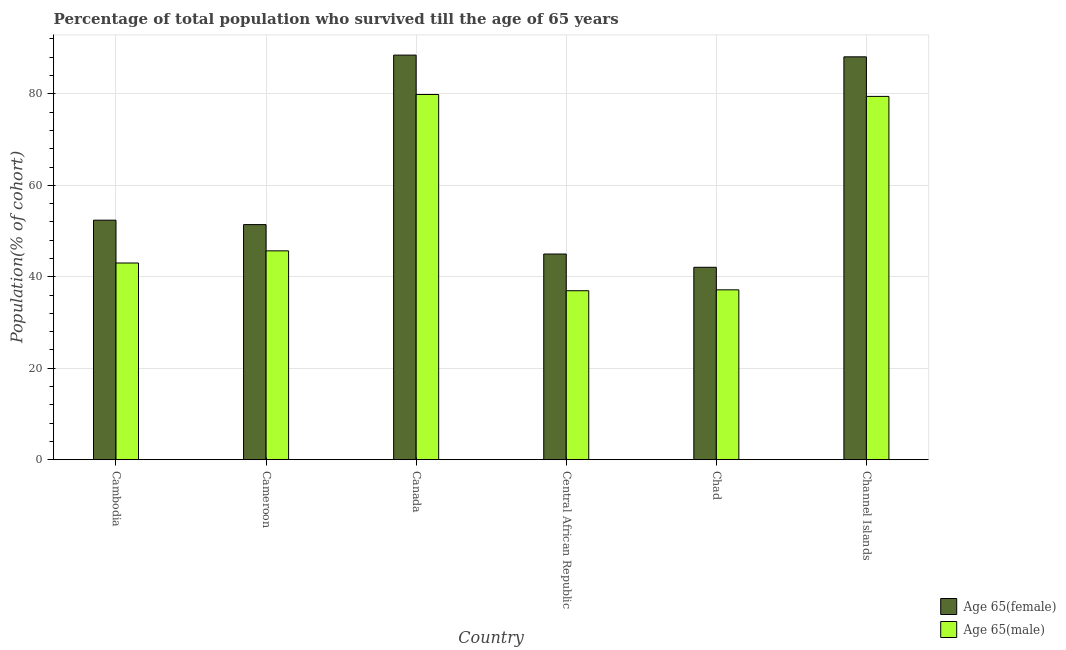Are the number of bars on each tick of the X-axis equal?
Offer a terse response. Yes. How many bars are there on the 4th tick from the left?
Provide a succinct answer. 2. How many bars are there on the 5th tick from the right?
Provide a succinct answer. 2. What is the label of the 6th group of bars from the left?
Keep it short and to the point. Channel Islands. In how many cases, is the number of bars for a given country not equal to the number of legend labels?
Your response must be concise. 0. What is the percentage of male population who survived till age of 65 in Canada?
Ensure brevity in your answer.  79.86. Across all countries, what is the maximum percentage of female population who survived till age of 65?
Provide a succinct answer. 88.47. Across all countries, what is the minimum percentage of female population who survived till age of 65?
Keep it short and to the point. 42.07. In which country was the percentage of male population who survived till age of 65 maximum?
Provide a short and direct response. Canada. In which country was the percentage of female population who survived till age of 65 minimum?
Offer a terse response. Chad. What is the total percentage of male population who survived till age of 65 in the graph?
Your answer should be compact. 322.07. What is the difference between the percentage of male population who survived till age of 65 in Chad and that in Channel Islands?
Give a very brief answer. -42.3. What is the difference between the percentage of female population who survived till age of 65 in Channel Islands and the percentage of male population who survived till age of 65 in Cameroon?
Keep it short and to the point. 42.42. What is the average percentage of male population who survived till age of 65 per country?
Give a very brief answer. 53.68. What is the difference between the percentage of male population who survived till age of 65 and percentage of female population who survived till age of 65 in Canada?
Ensure brevity in your answer.  -8.61. What is the ratio of the percentage of male population who survived till age of 65 in Cameroon to that in Channel Islands?
Offer a terse response. 0.57. Is the percentage of female population who survived till age of 65 in Cameroon less than that in Channel Islands?
Your answer should be compact. Yes. What is the difference between the highest and the second highest percentage of female population who survived till age of 65?
Give a very brief answer. 0.38. What is the difference between the highest and the lowest percentage of male population who survived till age of 65?
Your response must be concise. 42.91. In how many countries, is the percentage of male population who survived till age of 65 greater than the average percentage of male population who survived till age of 65 taken over all countries?
Your answer should be compact. 2. Is the sum of the percentage of male population who survived till age of 65 in Canada and Channel Islands greater than the maximum percentage of female population who survived till age of 65 across all countries?
Keep it short and to the point. Yes. What does the 1st bar from the left in Cameroon represents?
Offer a terse response. Age 65(female). What does the 1st bar from the right in Canada represents?
Keep it short and to the point. Age 65(male). How many countries are there in the graph?
Give a very brief answer. 6. What is the difference between two consecutive major ticks on the Y-axis?
Give a very brief answer. 20. Does the graph contain any zero values?
Your answer should be compact. No. Does the graph contain grids?
Your answer should be compact. Yes. How many legend labels are there?
Provide a succinct answer. 2. What is the title of the graph?
Offer a terse response. Percentage of total population who survived till the age of 65 years. What is the label or title of the X-axis?
Ensure brevity in your answer.  Country. What is the label or title of the Y-axis?
Provide a succinct answer. Population(% of cohort). What is the Population(% of cohort) of Age 65(female) in Cambodia?
Keep it short and to the point. 52.37. What is the Population(% of cohort) in Age 65(male) in Cambodia?
Offer a terse response. 43.01. What is the Population(% of cohort) of Age 65(female) in Cameroon?
Your answer should be compact. 51.41. What is the Population(% of cohort) in Age 65(male) in Cameroon?
Offer a terse response. 45.67. What is the Population(% of cohort) in Age 65(female) in Canada?
Your answer should be very brief. 88.47. What is the Population(% of cohort) in Age 65(male) in Canada?
Ensure brevity in your answer.  79.86. What is the Population(% of cohort) of Age 65(female) in Central African Republic?
Your answer should be very brief. 44.97. What is the Population(% of cohort) in Age 65(male) in Central African Republic?
Your answer should be compact. 36.95. What is the Population(% of cohort) of Age 65(female) in Chad?
Provide a short and direct response. 42.07. What is the Population(% of cohort) of Age 65(male) in Chad?
Your answer should be compact. 37.14. What is the Population(% of cohort) of Age 65(female) in Channel Islands?
Your answer should be compact. 88.09. What is the Population(% of cohort) of Age 65(male) in Channel Islands?
Keep it short and to the point. 79.44. Across all countries, what is the maximum Population(% of cohort) of Age 65(female)?
Ensure brevity in your answer.  88.47. Across all countries, what is the maximum Population(% of cohort) in Age 65(male)?
Provide a succinct answer. 79.86. Across all countries, what is the minimum Population(% of cohort) of Age 65(female)?
Make the answer very short. 42.07. Across all countries, what is the minimum Population(% of cohort) of Age 65(male)?
Ensure brevity in your answer.  36.95. What is the total Population(% of cohort) of Age 65(female) in the graph?
Provide a succinct answer. 367.39. What is the total Population(% of cohort) of Age 65(male) in the graph?
Offer a very short reply. 322.07. What is the difference between the Population(% of cohort) of Age 65(female) in Cambodia and that in Cameroon?
Offer a very short reply. 0.96. What is the difference between the Population(% of cohort) in Age 65(male) in Cambodia and that in Cameroon?
Your response must be concise. -2.66. What is the difference between the Population(% of cohort) of Age 65(female) in Cambodia and that in Canada?
Your answer should be compact. -36.1. What is the difference between the Population(% of cohort) in Age 65(male) in Cambodia and that in Canada?
Your answer should be very brief. -36.85. What is the difference between the Population(% of cohort) of Age 65(female) in Cambodia and that in Central African Republic?
Offer a very short reply. 7.4. What is the difference between the Population(% of cohort) of Age 65(male) in Cambodia and that in Central African Republic?
Keep it short and to the point. 6.06. What is the difference between the Population(% of cohort) of Age 65(female) in Cambodia and that in Chad?
Give a very brief answer. 10.3. What is the difference between the Population(% of cohort) in Age 65(male) in Cambodia and that in Chad?
Make the answer very short. 5.86. What is the difference between the Population(% of cohort) in Age 65(female) in Cambodia and that in Channel Islands?
Offer a very short reply. -35.72. What is the difference between the Population(% of cohort) of Age 65(male) in Cambodia and that in Channel Islands?
Your response must be concise. -36.43. What is the difference between the Population(% of cohort) in Age 65(female) in Cameroon and that in Canada?
Offer a very short reply. -37.06. What is the difference between the Population(% of cohort) in Age 65(male) in Cameroon and that in Canada?
Give a very brief answer. -34.19. What is the difference between the Population(% of cohort) in Age 65(female) in Cameroon and that in Central African Republic?
Provide a succinct answer. 6.44. What is the difference between the Population(% of cohort) of Age 65(male) in Cameroon and that in Central African Republic?
Your response must be concise. 8.72. What is the difference between the Population(% of cohort) in Age 65(female) in Cameroon and that in Chad?
Your answer should be compact. 9.34. What is the difference between the Population(% of cohort) of Age 65(male) in Cameroon and that in Chad?
Keep it short and to the point. 8.52. What is the difference between the Population(% of cohort) in Age 65(female) in Cameroon and that in Channel Islands?
Offer a terse response. -36.68. What is the difference between the Population(% of cohort) of Age 65(male) in Cameroon and that in Channel Islands?
Give a very brief answer. -33.77. What is the difference between the Population(% of cohort) in Age 65(female) in Canada and that in Central African Republic?
Your response must be concise. 43.5. What is the difference between the Population(% of cohort) in Age 65(male) in Canada and that in Central African Republic?
Provide a succinct answer. 42.91. What is the difference between the Population(% of cohort) of Age 65(female) in Canada and that in Chad?
Make the answer very short. 46.4. What is the difference between the Population(% of cohort) in Age 65(male) in Canada and that in Chad?
Provide a succinct answer. 42.71. What is the difference between the Population(% of cohort) in Age 65(female) in Canada and that in Channel Islands?
Provide a succinct answer. 0.38. What is the difference between the Population(% of cohort) in Age 65(male) in Canada and that in Channel Islands?
Provide a short and direct response. 0.41. What is the difference between the Population(% of cohort) of Age 65(female) in Central African Republic and that in Chad?
Your response must be concise. 2.9. What is the difference between the Population(% of cohort) of Age 65(male) in Central African Republic and that in Chad?
Your answer should be compact. -0.2. What is the difference between the Population(% of cohort) in Age 65(female) in Central African Republic and that in Channel Islands?
Provide a short and direct response. -43.12. What is the difference between the Population(% of cohort) of Age 65(male) in Central African Republic and that in Channel Islands?
Ensure brevity in your answer.  -42.49. What is the difference between the Population(% of cohort) in Age 65(female) in Chad and that in Channel Islands?
Keep it short and to the point. -46.02. What is the difference between the Population(% of cohort) in Age 65(male) in Chad and that in Channel Islands?
Keep it short and to the point. -42.3. What is the difference between the Population(% of cohort) of Age 65(female) in Cambodia and the Population(% of cohort) of Age 65(male) in Cameroon?
Your response must be concise. 6.71. What is the difference between the Population(% of cohort) in Age 65(female) in Cambodia and the Population(% of cohort) in Age 65(male) in Canada?
Provide a short and direct response. -27.48. What is the difference between the Population(% of cohort) in Age 65(female) in Cambodia and the Population(% of cohort) in Age 65(male) in Central African Republic?
Ensure brevity in your answer.  15.42. What is the difference between the Population(% of cohort) in Age 65(female) in Cambodia and the Population(% of cohort) in Age 65(male) in Chad?
Offer a terse response. 15.23. What is the difference between the Population(% of cohort) of Age 65(female) in Cambodia and the Population(% of cohort) of Age 65(male) in Channel Islands?
Keep it short and to the point. -27.07. What is the difference between the Population(% of cohort) in Age 65(female) in Cameroon and the Population(% of cohort) in Age 65(male) in Canada?
Keep it short and to the point. -28.45. What is the difference between the Population(% of cohort) of Age 65(female) in Cameroon and the Population(% of cohort) of Age 65(male) in Central African Republic?
Give a very brief answer. 14.46. What is the difference between the Population(% of cohort) of Age 65(female) in Cameroon and the Population(% of cohort) of Age 65(male) in Chad?
Your answer should be compact. 14.27. What is the difference between the Population(% of cohort) in Age 65(female) in Cameroon and the Population(% of cohort) in Age 65(male) in Channel Islands?
Your answer should be very brief. -28.03. What is the difference between the Population(% of cohort) of Age 65(female) in Canada and the Population(% of cohort) of Age 65(male) in Central African Republic?
Provide a succinct answer. 51.52. What is the difference between the Population(% of cohort) of Age 65(female) in Canada and the Population(% of cohort) of Age 65(male) in Chad?
Your response must be concise. 51.33. What is the difference between the Population(% of cohort) of Age 65(female) in Canada and the Population(% of cohort) of Age 65(male) in Channel Islands?
Keep it short and to the point. 9.03. What is the difference between the Population(% of cohort) of Age 65(female) in Central African Republic and the Population(% of cohort) of Age 65(male) in Chad?
Make the answer very short. 7.83. What is the difference between the Population(% of cohort) of Age 65(female) in Central African Republic and the Population(% of cohort) of Age 65(male) in Channel Islands?
Your answer should be compact. -34.47. What is the difference between the Population(% of cohort) in Age 65(female) in Chad and the Population(% of cohort) in Age 65(male) in Channel Islands?
Your response must be concise. -37.37. What is the average Population(% of cohort) of Age 65(female) per country?
Provide a short and direct response. 61.23. What is the average Population(% of cohort) of Age 65(male) per country?
Your answer should be very brief. 53.68. What is the difference between the Population(% of cohort) of Age 65(female) and Population(% of cohort) of Age 65(male) in Cambodia?
Provide a succinct answer. 9.36. What is the difference between the Population(% of cohort) in Age 65(female) and Population(% of cohort) in Age 65(male) in Cameroon?
Your answer should be compact. 5.74. What is the difference between the Population(% of cohort) of Age 65(female) and Population(% of cohort) of Age 65(male) in Canada?
Your response must be concise. 8.61. What is the difference between the Population(% of cohort) in Age 65(female) and Population(% of cohort) in Age 65(male) in Central African Republic?
Make the answer very short. 8.02. What is the difference between the Population(% of cohort) of Age 65(female) and Population(% of cohort) of Age 65(male) in Chad?
Offer a terse response. 4.93. What is the difference between the Population(% of cohort) of Age 65(female) and Population(% of cohort) of Age 65(male) in Channel Islands?
Keep it short and to the point. 8.65. What is the ratio of the Population(% of cohort) of Age 65(female) in Cambodia to that in Cameroon?
Provide a succinct answer. 1.02. What is the ratio of the Population(% of cohort) in Age 65(male) in Cambodia to that in Cameroon?
Your response must be concise. 0.94. What is the ratio of the Population(% of cohort) in Age 65(female) in Cambodia to that in Canada?
Make the answer very short. 0.59. What is the ratio of the Population(% of cohort) in Age 65(male) in Cambodia to that in Canada?
Ensure brevity in your answer.  0.54. What is the ratio of the Population(% of cohort) of Age 65(female) in Cambodia to that in Central African Republic?
Make the answer very short. 1.16. What is the ratio of the Population(% of cohort) of Age 65(male) in Cambodia to that in Central African Republic?
Give a very brief answer. 1.16. What is the ratio of the Population(% of cohort) of Age 65(female) in Cambodia to that in Chad?
Offer a terse response. 1.24. What is the ratio of the Population(% of cohort) in Age 65(male) in Cambodia to that in Chad?
Your answer should be compact. 1.16. What is the ratio of the Population(% of cohort) of Age 65(female) in Cambodia to that in Channel Islands?
Give a very brief answer. 0.59. What is the ratio of the Population(% of cohort) of Age 65(male) in Cambodia to that in Channel Islands?
Your answer should be very brief. 0.54. What is the ratio of the Population(% of cohort) in Age 65(female) in Cameroon to that in Canada?
Give a very brief answer. 0.58. What is the ratio of the Population(% of cohort) of Age 65(male) in Cameroon to that in Canada?
Offer a terse response. 0.57. What is the ratio of the Population(% of cohort) in Age 65(female) in Cameroon to that in Central African Republic?
Offer a terse response. 1.14. What is the ratio of the Population(% of cohort) in Age 65(male) in Cameroon to that in Central African Republic?
Offer a terse response. 1.24. What is the ratio of the Population(% of cohort) in Age 65(female) in Cameroon to that in Chad?
Give a very brief answer. 1.22. What is the ratio of the Population(% of cohort) in Age 65(male) in Cameroon to that in Chad?
Your answer should be compact. 1.23. What is the ratio of the Population(% of cohort) in Age 65(female) in Cameroon to that in Channel Islands?
Provide a short and direct response. 0.58. What is the ratio of the Population(% of cohort) of Age 65(male) in Cameroon to that in Channel Islands?
Your answer should be very brief. 0.57. What is the ratio of the Population(% of cohort) of Age 65(female) in Canada to that in Central African Republic?
Offer a terse response. 1.97. What is the ratio of the Population(% of cohort) of Age 65(male) in Canada to that in Central African Republic?
Provide a short and direct response. 2.16. What is the ratio of the Population(% of cohort) in Age 65(female) in Canada to that in Chad?
Your answer should be compact. 2.1. What is the ratio of the Population(% of cohort) of Age 65(male) in Canada to that in Chad?
Keep it short and to the point. 2.15. What is the ratio of the Population(% of cohort) in Age 65(female) in Canada to that in Channel Islands?
Your answer should be compact. 1. What is the ratio of the Population(% of cohort) of Age 65(female) in Central African Republic to that in Chad?
Offer a very short reply. 1.07. What is the ratio of the Population(% of cohort) in Age 65(female) in Central African Republic to that in Channel Islands?
Your answer should be compact. 0.51. What is the ratio of the Population(% of cohort) in Age 65(male) in Central African Republic to that in Channel Islands?
Offer a terse response. 0.47. What is the ratio of the Population(% of cohort) in Age 65(female) in Chad to that in Channel Islands?
Ensure brevity in your answer.  0.48. What is the ratio of the Population(% of cohort) of Age 65(male) in Chad to that in Channel Islands?
Ensure brevity in your answer.  0.47. What is the difference between the highest and the second highest Population(% of cohort) in Age 65(female)?
Make the answer very short. 0.38. What is the difference between the highest and the second highest Population(% of cohort) of Age 65(male)?
Your answer should be compact. 0.41. What is the difference between the highest and the lowest Population(% of cohort) of Age 65(female)?
Provide a short and direct response. 46.4. What is the difference between the highest and the lowest Population(% of cohort) in Age 65(male)?
Your answer should be compact. 42.91. 